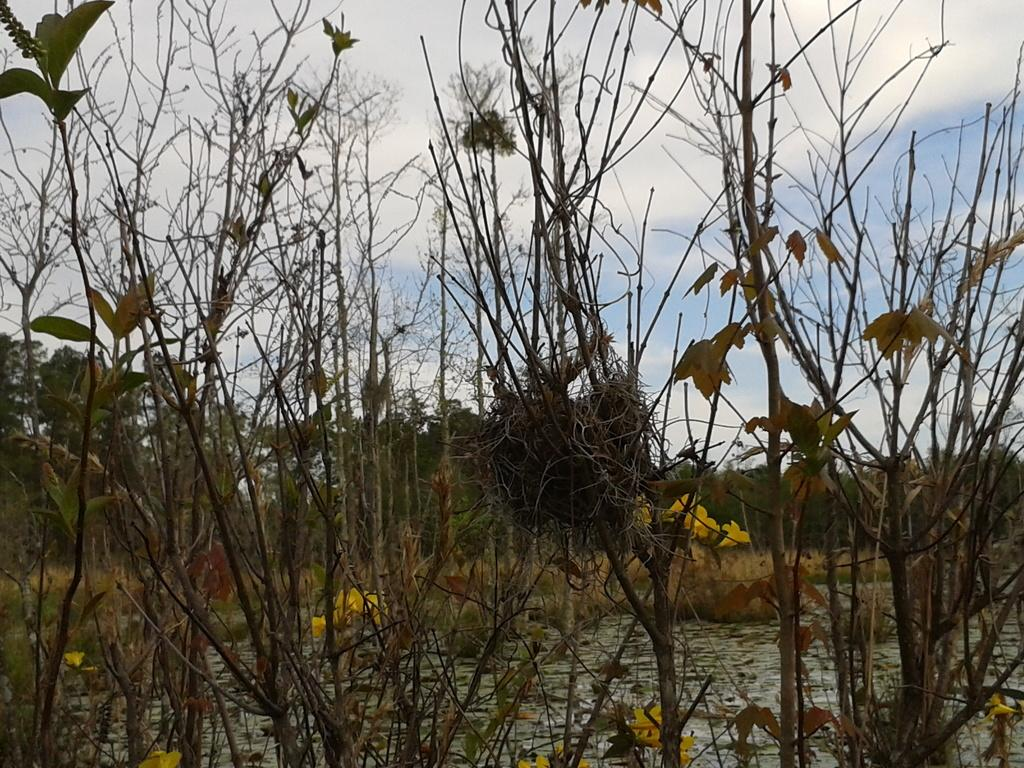What type of vegetation can be seen in the image? There are dry plants, bushes, and trees in the image. What color is the sky in the image? The sky is blue in the image. What type of animal can be seen at the market in the image? There is no animal or market present in the image; it features dry plants, bushes, trees, and a blue sky. What religious belief is depicted in the image? There is no religious symbol or belief depicted in the image; it focuses on the vegetation and sky. 